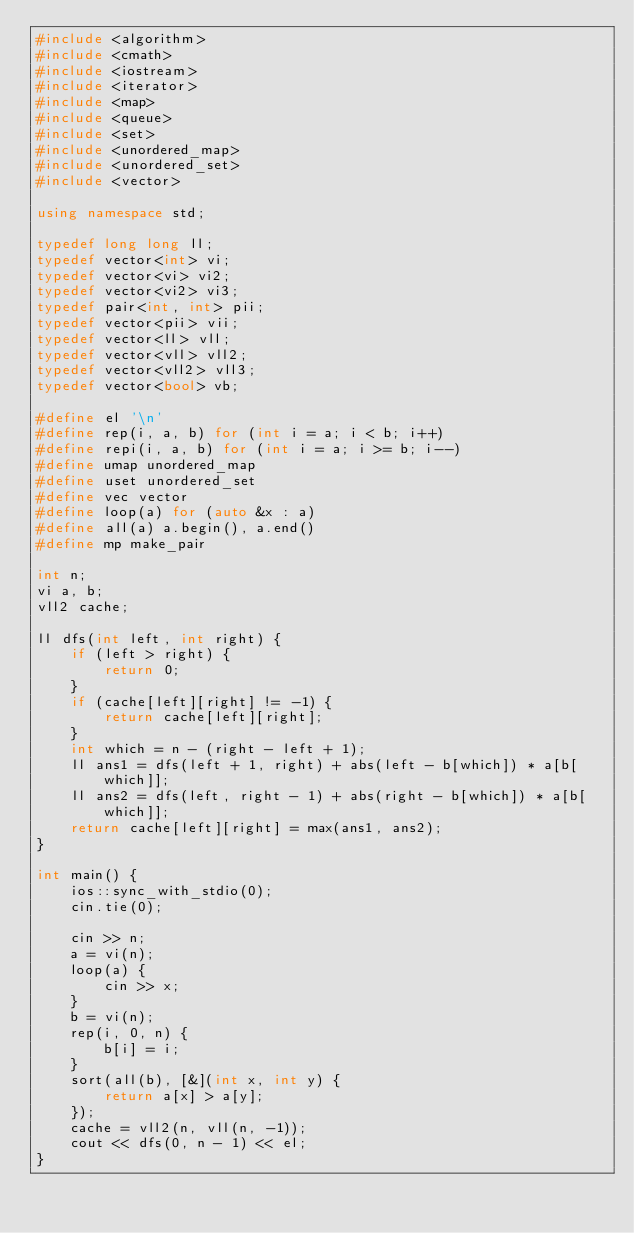<code> <loc_0><loc_0><loc_500><loc_500><_C++_>#include <algorithm>
#include <cmath>
#include <iostream>
#include <iterator>
#include <map>
#include <queue>
#include <set>
#include <unordered_map>
#include <unordered_set>
#include <vector>

using namespace std;

typedef long long ll;
typedef vector<int> vi;
typedef vector<vi> vi2;
typedef vector<vi2> vi3;
typedef pair<int, int> pii;
typedef vector<pii> vii;
typedef vector<ll> vll;
typedef vector<vll> vll2;
typedef vector<vll2> vll3;
typedef vector<bool> vb;

#define el '\n'
#define rep(i, a, b) for (int i = a; i < b; i++)
#define repi(i, a, b) for (int i = a; i >= b; i--)
#define umap unordered_map
#define uset unordered_set
#define vec vector
#define loop(a) for (auto &x : a)
#define all(a) a.begin(), a.end()
#define mp make_pair

int n;
vi a, b;
vll2 cache;

ll dfs(int left, int right) {
    if (left > right) {
        return 0;
    }
    if (cache[left][right] != -1) {
        return cache[left][right];
    }
    int which = n - (right - left + 1);
    ll ans1 = dfs(left + 1, right) + abs(left - b[which]) * a[b[which]];
    ll ans2 = dfs(left, right - 1) + abs(right - b[which]) * a[b[which]];
    return cache[left][right] = max(ans1, ans2);
}

int main() {
    ios::sync_with_stdio(0);
    cin.tie(0);

    cin >> n;
    a = vi(n);
    loop(a) {
        cin >> x;
    }
    b = vi(n);
    rep(i, 0, n) {
        b[i] = i;
    }
    sort(all(b), [&](int x, int y) {
        return a[x] > a[y];
    });
    cache = vll2(n, vll(n, -1));
    cout << dfs(0, n - 1) << el;
}
</code> 